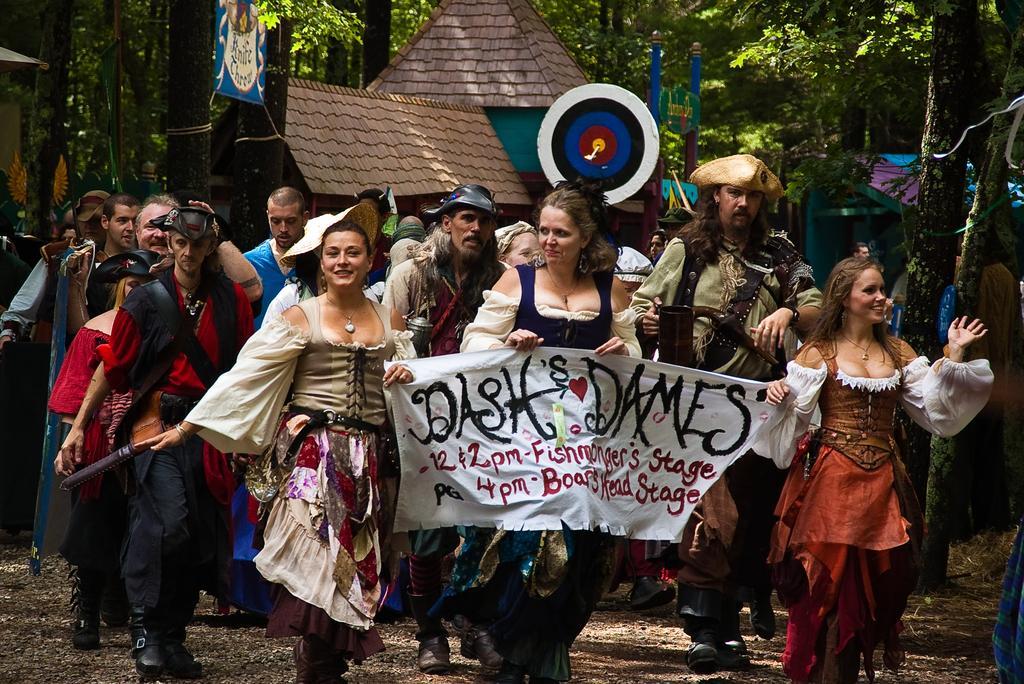Could you give a brief overview of what you see in this image? In this picture there are group of people with costumes are walking and in the foreground there are three persons walking and holding the banner and there is a text on the banner. At the back there are buildings and trees and there is a hoarding. At the bottom there is mud. 